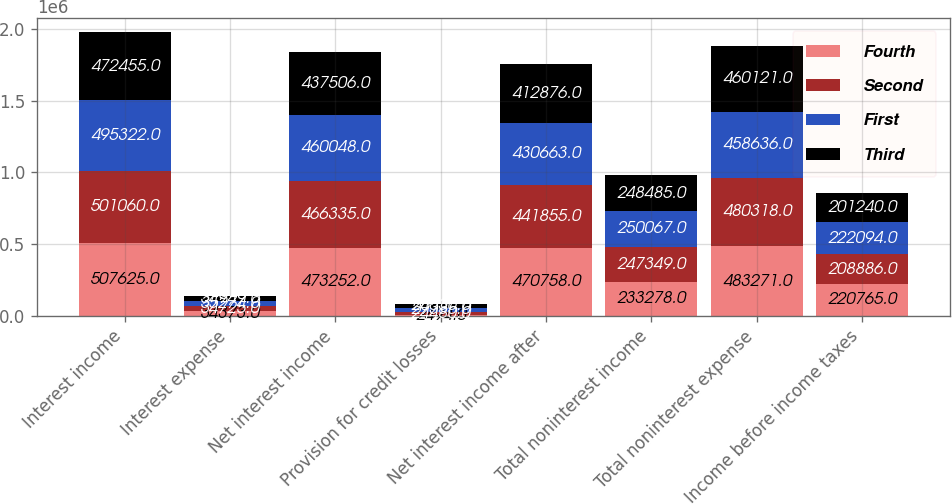Convert chart. <chart><loc_0><loc_0><loc_500><loc_500><stacked_bar_chart><ecel><fcel>Interest income<fcel>Interest expense<fcel>Net interest income<fcel>Provision for credit losses<fcel>Net interest income after<fcel>Total noninterest income<fcel>Total noninterest expense<fcel>Income before income taxes<nl><fcel>Fourth<fcel>507625<fcel>34373<fcel>473252<fcel>2494<fcel>470758<fcel>233278<fcel>483271<fcel>220765<nl><fcel>Second<fcel>501060<fcel>34725<fcel>466335<fcel>24480<fcel>441855<fcel>247349<fcel>480318<fcel>208886<nl><fcel>First<fcel>495322<fcel>35274<fcel>460048<fcel>29385<fcel>430663<fcel>250067<fcel>458636<fcel>222094<nl><fcel>Third<fcel>472455<fcel>34949<fcel>437506<fcel>24630<fcel>412876<fcel>248485<fcel>460121<fcel>201240<nl></chart> 